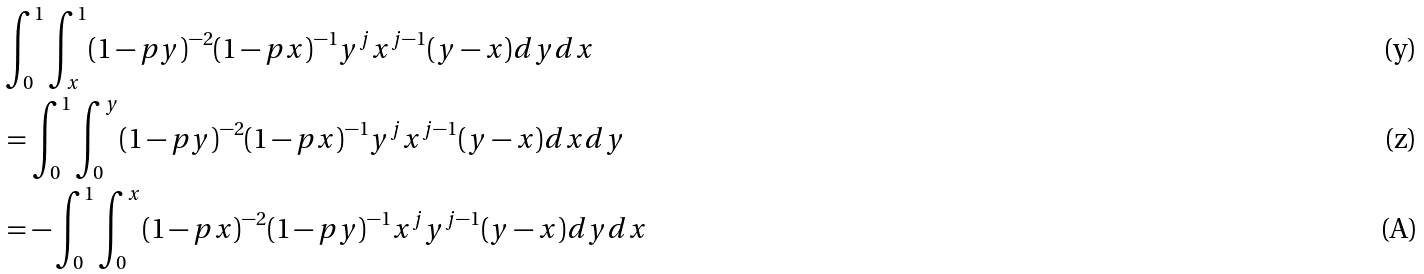<formula> <loc_0><loc_0><loc_500><loc_500>& \int _ { 0 } ^ { 1 } \int _ { x } ^ { 1 } ( 1 - p y ) ^ { - 2 } ( 1 - p x ) ^ { - 1 } y ^ { j } x ^ { j - 1 } ( y - x ) d y d x \\ & = \int _ { 0 } ^ { 1 } \int _ { 0 } ^ { y } ( 1 - p y ) ^ { - 2 } ( 1 - p x ) ^ { - 1 } y ^ { j } x ^ { j - 1 } ( y - x ) d x d y \\ & = - \int _ { 0 } ^ { 1 } \int _ { 0 } ^ { x } ( 1 - p x ) ^ { - 2 } ( 1 - p y ) ^ { - 1 } x ^ { j } y ^ { j - 1 } ( y - x ) d y d x</formula> 